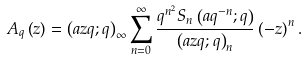Convert formula to latex. <formula><loc_0><loc_0><loc_500><loc_500>A _ { q } \left ( z \right ) = \left ( a z q ; q \right ) _ { \infty } \sum _ { n = 0 } ^ { \infty } \frac { q ^ { n ^ { 2 } } S _ { n } \left ( a q ^ { - n } ; q \right ) } { \left ( a z q ; q \right ) _ { n } } \left ( - z \right ) ^ { n } .</formula> 